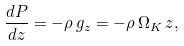Convert formula to latex. <formula><loc_0><loc_0><loc_500><loc_500>\frac { d P } { d z } = - \rho \, g _ { z } = - \rho \, \Omega _ { K } \, z ,</formula> 